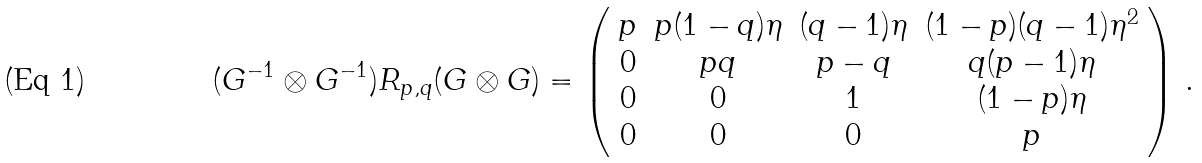Convert formula to latex. <formula><loc_0><loc_0><loc_500><loc_500>( G ^ { - 1 } \otimes G ^ { - 1 } ) R _ { p , q } ( G \otimes G ) = \left ( \begin{array} { c c c c } p & p ( 1 - q ) \eta & ( q - 1 ) \eta & ( 1 - p ) ( q - 1 ) \eta ^ { 2 } \\ 0 & p q & p - q & q ( p - 1 ) \eta \\ 0 & 0 & 1 & ( 1 - p ) \eta \\ 0 & 0 & 0 & p \end{array} \right ) \, .</formula> 